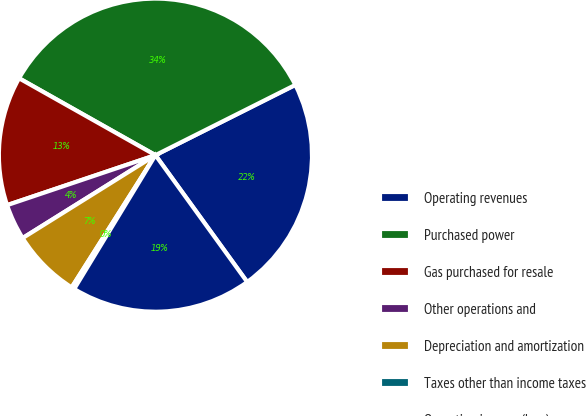Convert chart. <chart><loc_0><loc_0><loc_500><loc_500><pie_chart><fcel>Operating revenues<fcel>Purchased power<fcel>Gas purchased for resale<fcel>Other operations and<fcel>Depreciation and amortization<fcel>Taxes other than income taxes<fcel>Operating income (loss)<nl><fcel>22.44%<fcel>34.42%<fcel>13.34%<fcel>3.71%<fcel>7.13%<fcel>0.3%<fcel>18.65%<nl></chart> 